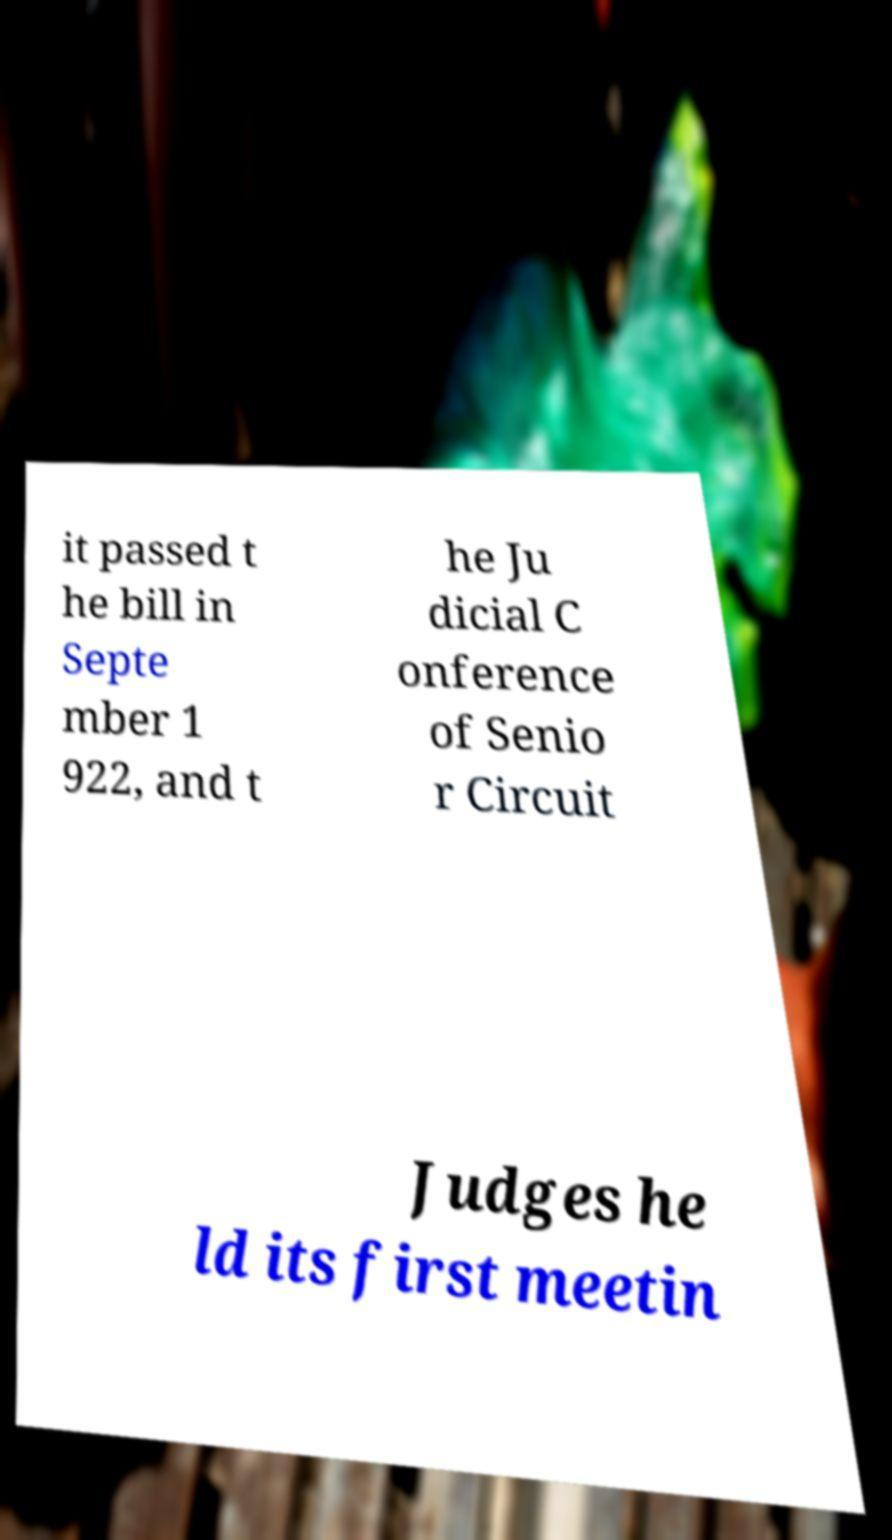Please read and relay the text visible in this image. What does it say? it passed t he bill in Septe mber 1 922, and t he Ju dicial C onference of Senio r Circuit Judges he ld its first meetin 